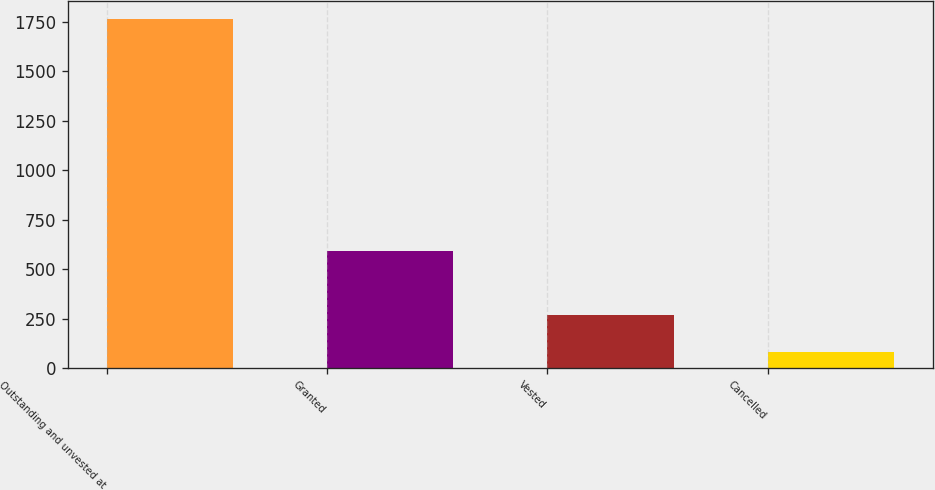<chart> <loc_0><loc_0><loc_500><loc_500><bar_chart><fcel>Outstanding and unvested at<fcel>Granted<fcel>Vested<fcel>Cancelled<nl><fcel>1764<fcel>592<fcel>266<fcel>83<nl></chart> 